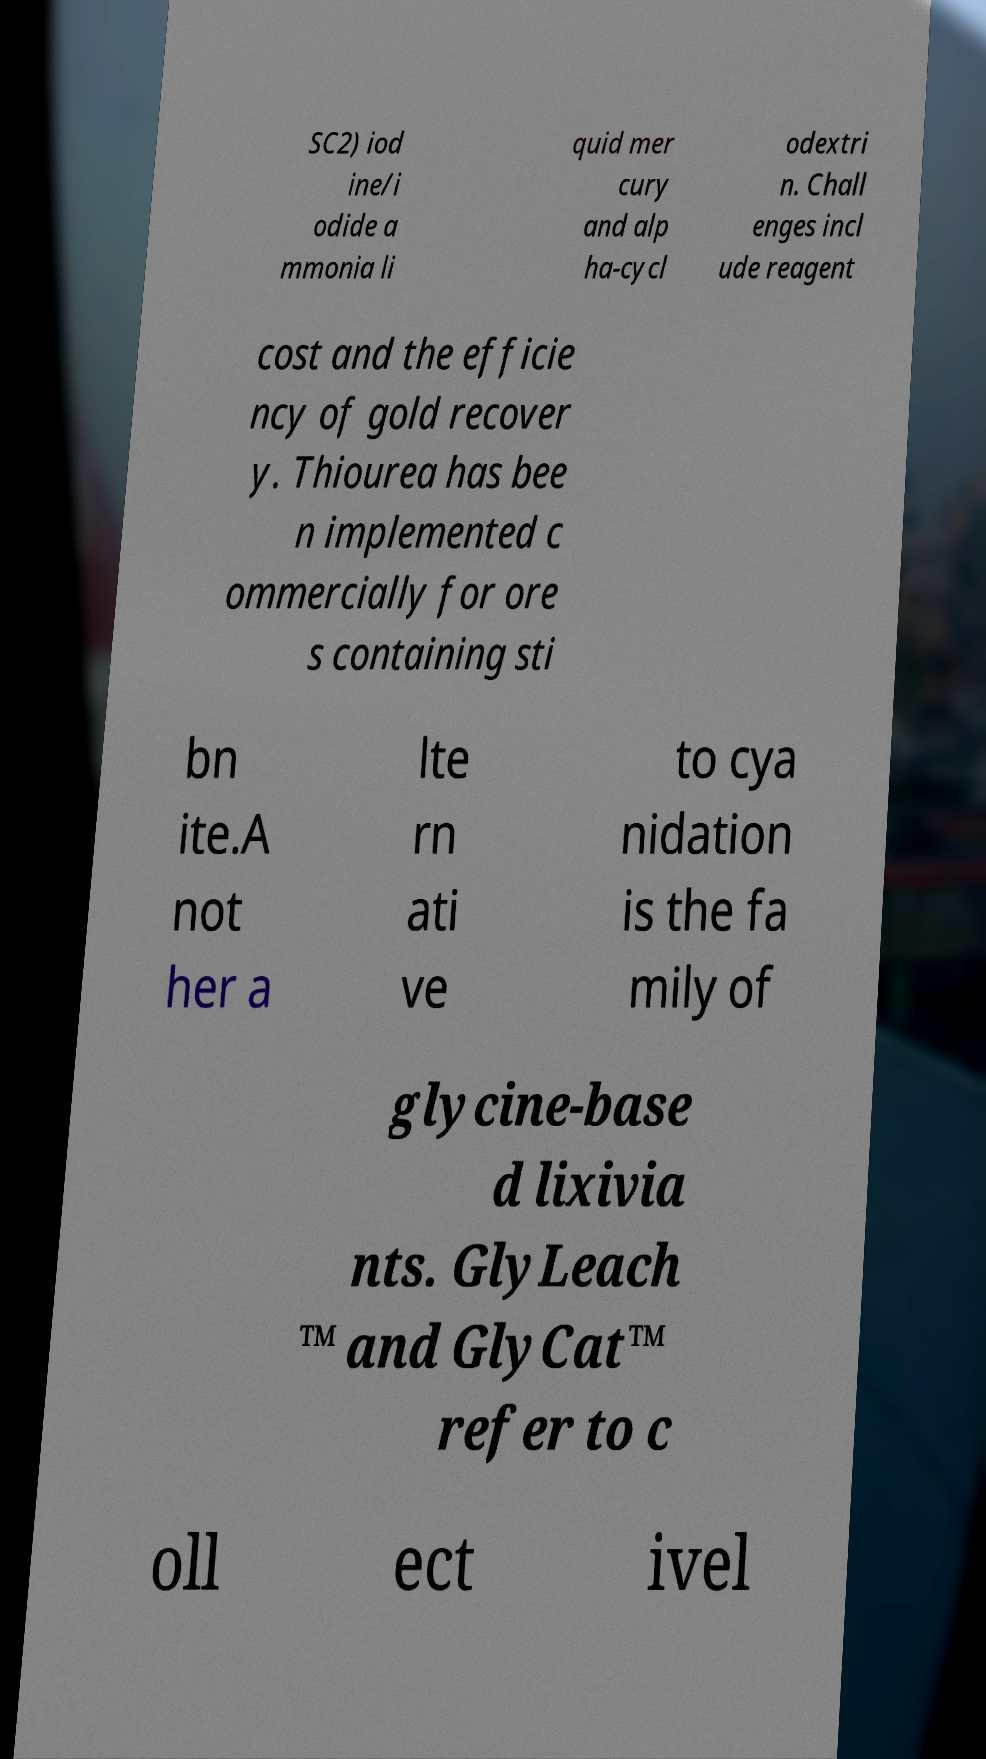Please read and relay the text visible in this image. What does it say? SC2) iod ine/i odide a mmonia li quid mer cury and alp ha-cycl odextri n. Chall enges incl ude reagent cost and the efficie ncy of gold recover y. Thiourea has bee n implemented c ommercially for ore s containing sti bn ite.A not her a lte rn ati ve to cya nidation is the fa mily of glycine-base d lixivia nts. GlyLeach ™ and GlyCat™ refer to c oll ect ivel 